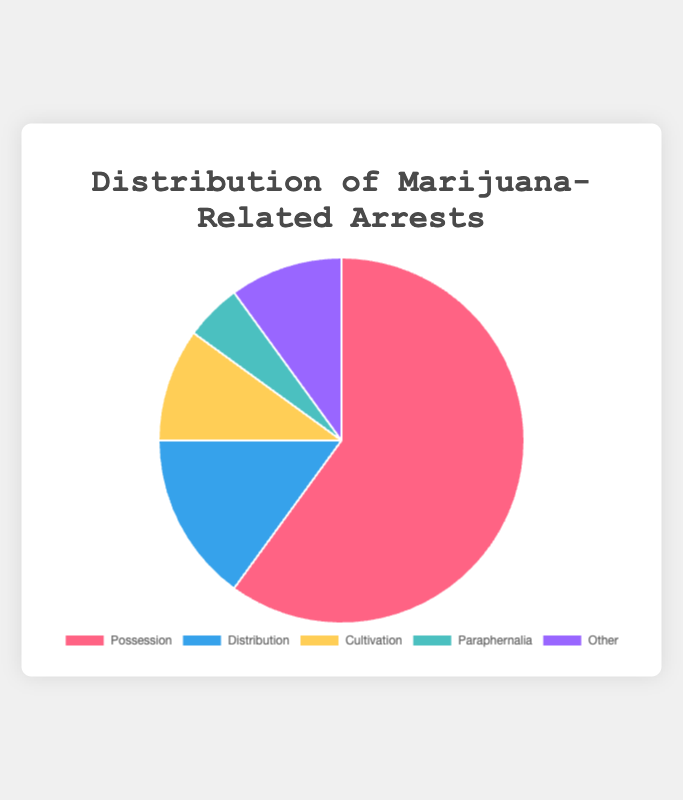Which category has the highest percentage of marijuana-related arrests? The chart shows the distribution of marijuana-related arrests across different categories. The segment with the largest percentage represents the highest category.
Answer: Possession What is the combined percentage of arrests for Cultivation and Paraphernalia? Add the percentage of arrests for Cultivation (10%) and Paraphernalia (5%). 10% + 5% = 15%
Answer: 15% Which category represents exactly 10% of the arrests? Look at the chart and identify the segments that correspond to 10%. "Cultivation" and "Other" both represent 10% of the arrests.
Answer: Cultivation, Other How much larger is the percentage of Possession arrests compared to Distribution arrests? Subtract the percentage of Distribution arrests (15%) from Possession arrests (60%). 60% - 15% = 45%
Answer: 45% What is the average percentage of arrests for Distribution, Cultivation, and Other? Add the percentages of Distribution (15%), Cultivation (10%), and Other (10%), then divide by 3. (15% + 10% + 10%) / 3 = 35% / 3 ≈ 11.67%
Answer: 11.67% Which category is represented by the color blue in the chart? By looking at the color-coding in the chart, identify which segment is represented by the color blue. The legend shows that Distribution is represented by blue.
Answer: Distribution Is the percentage of Paraphernalia arrests greater than 50% of the Cultivation arrests? Calculate 50% of Cultivation arrests (10%), which is 5%. Compare this with the percentage of Paraphernalia arrests (5%). Since 5% is equal to 5%, the answer is no.
Answer: No Arrange the categories in ascending order based on the percentage of arrests. List the arrest categories from the smallest to the largest percentage by examining the chart: Paraphernalia (5%), Cultivation (10%), Other (10%), Distribution (15%), and Possession (60%)
Answer: Paraphernalia, Cultivation, Other, Distribution, Possession What is the difference in the percentage of arrests between the category with the most arrests and the one with the least arrests? Subtract the percentage of Paraphernalia arrests (5%) from the percentage of Possession arrests (60%). 60% - 5% = 55%
Answer: 55% 